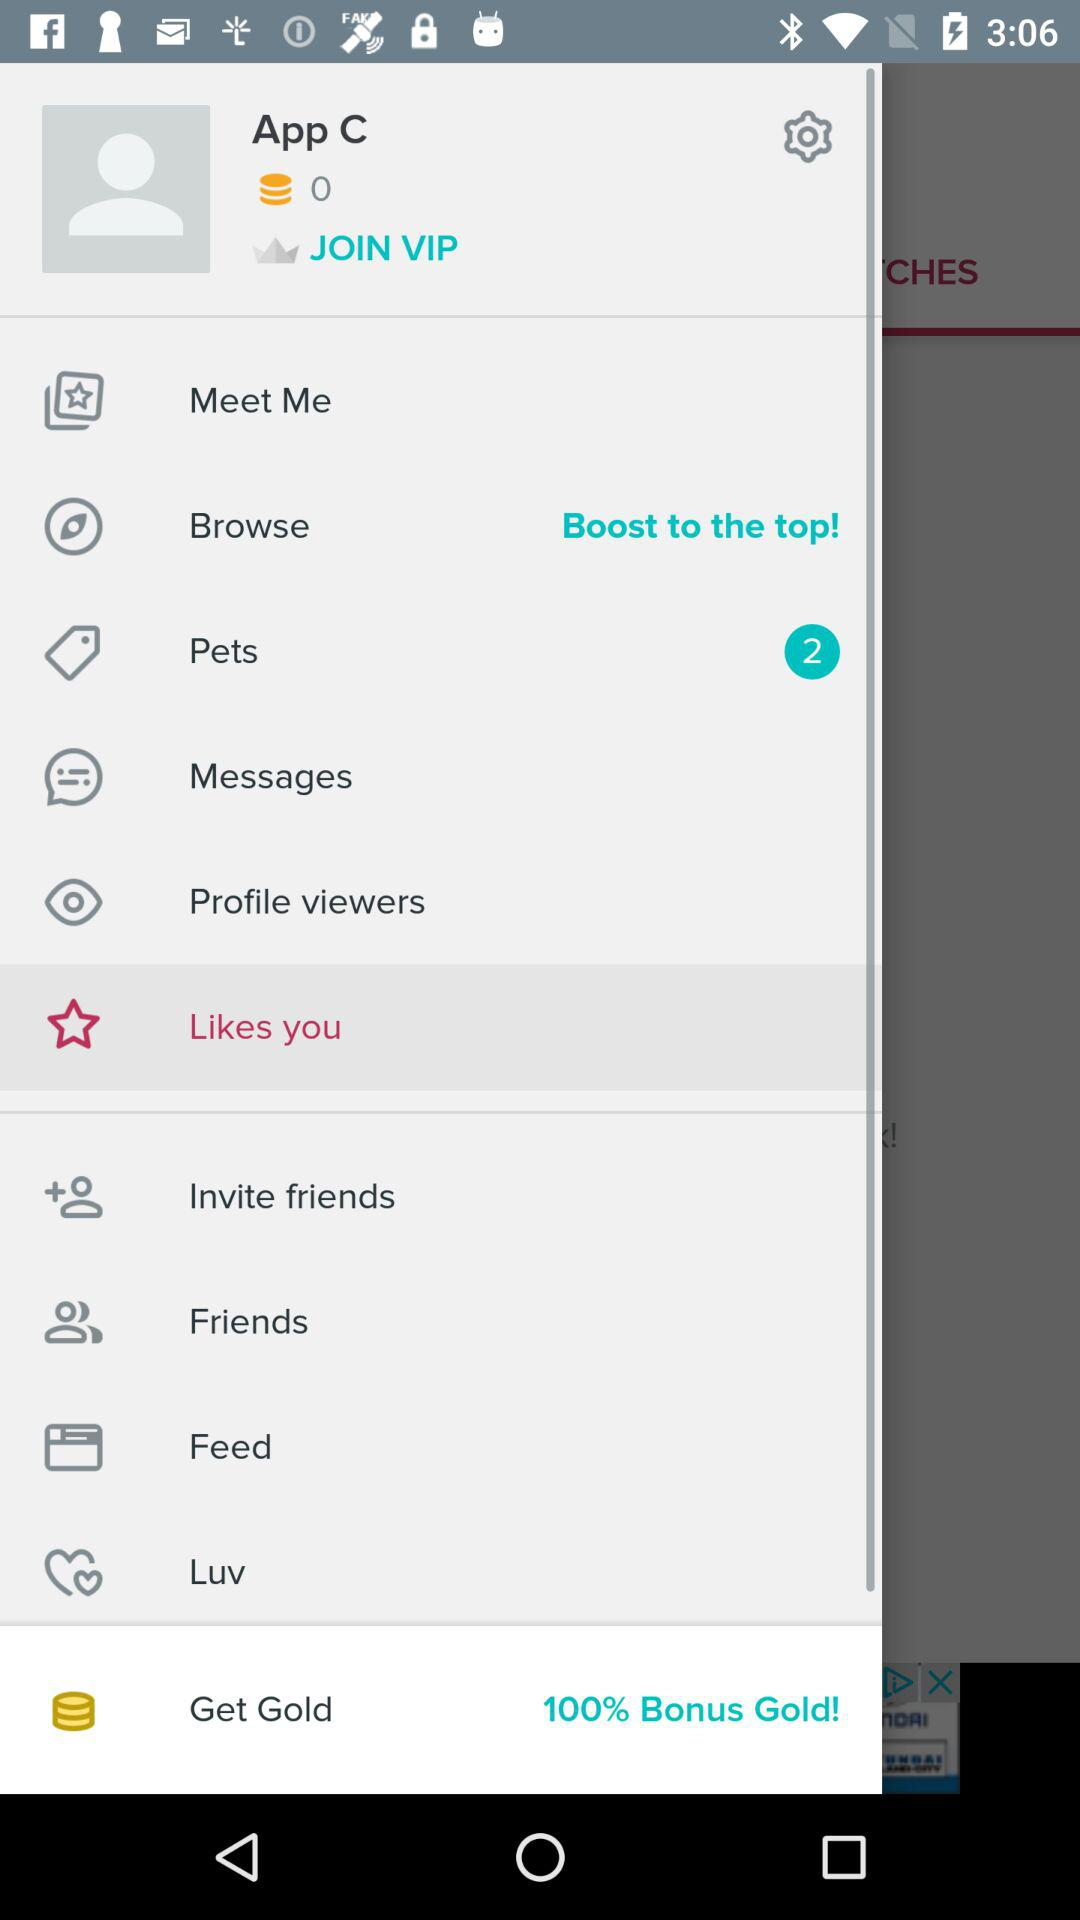How many pets in total are there? There are 2 pets in total. 